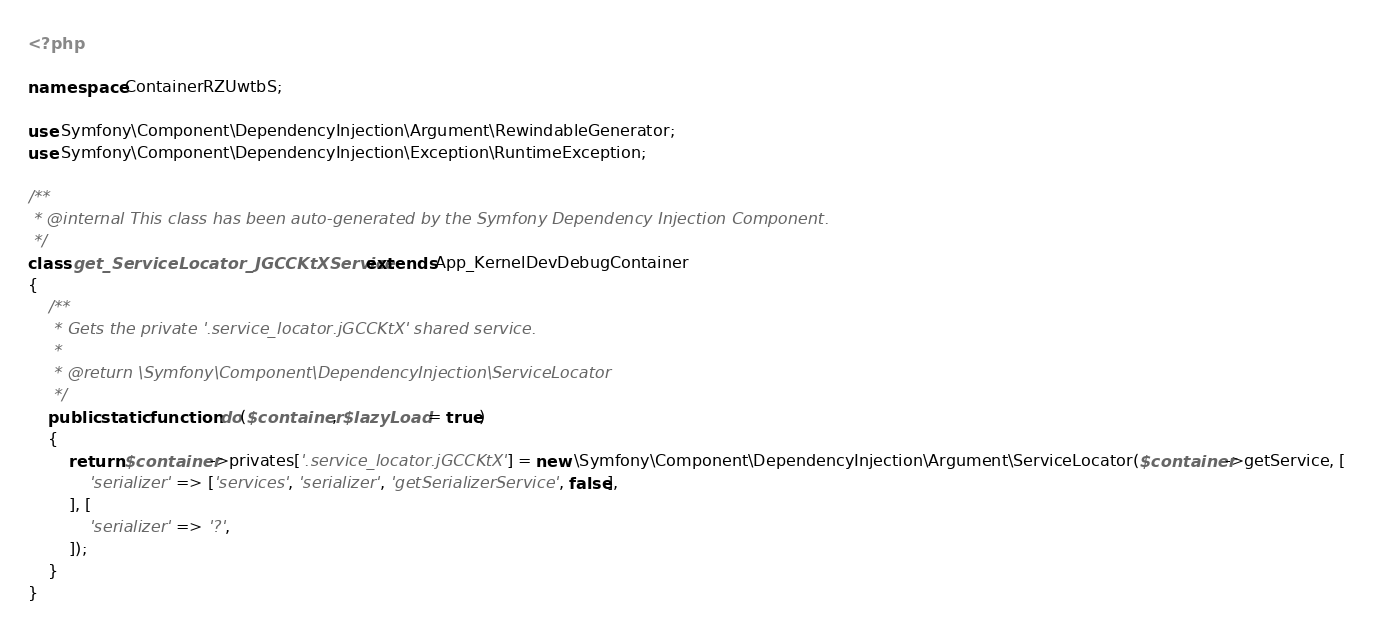Convert code to text. <code><loc_0><loc_0><loc_500><loc_500><_PHP_><?php

namespace ContainerRZUwtbS;

use Symfony\Component\DependencyInjection\Argument\RewindableGenerator;
use Symfony\Component\DependencyInjection\Exception\RuntimeException;

/**
 * @internal This class has been auto-generated by the Symfony Dependency Injection Component.
 */
class get_ServiceLocator_JGCCKtXService extends App_KernelDevDebugContainer
{
    /**
     * Gets the private '.service_locator.jGCCKtX' shared service.
     *
     * @return \Symfony\Component\DependencyInjection\ServiceLocator
     */
    public static function do($container, $lazyLoad = true)
    {
        return $container->privates['.service_locator.jGCCKtX'] = new \Symfony\Component\DependencyInjection\Argument\ServiceLocator($container->getService, [
            'serializer' => ['services', 'serializer', 'getSerializerService', false],
        ], [
            'serializer' => '?',
        ]);
    }
}
</code> 